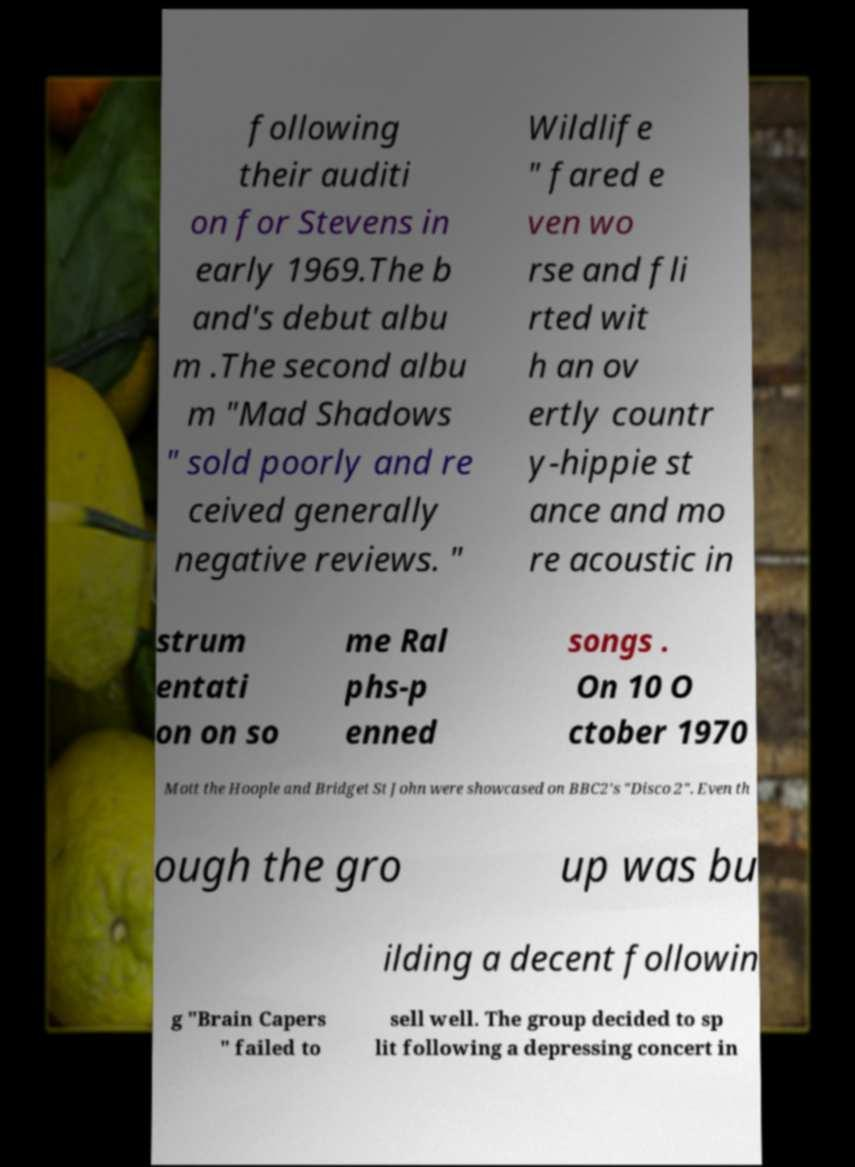Please read and relay the text visible in this image. What does it say? following their auditi on for Stevens in early 1969.The b and's debut albu m .The second albu m "Mad Shadows " sold poorly and re ceived generally negative reviews. " Wildlife " fared e ven wo rse and fli rted wit h an ov ertly countr y-hippie st ance and mo re acoustic in strum entati on on so me Ral phs-p enned songs . On 10 O ctober 1970 Mott the Hoople and Bridget St John were showcased on BBC2's "Disco 2". Even th ough the gro up was bu ilding a decent followin g "Brain Capers " failed to sell well. The group decided to sp lit following a depressing concert in 